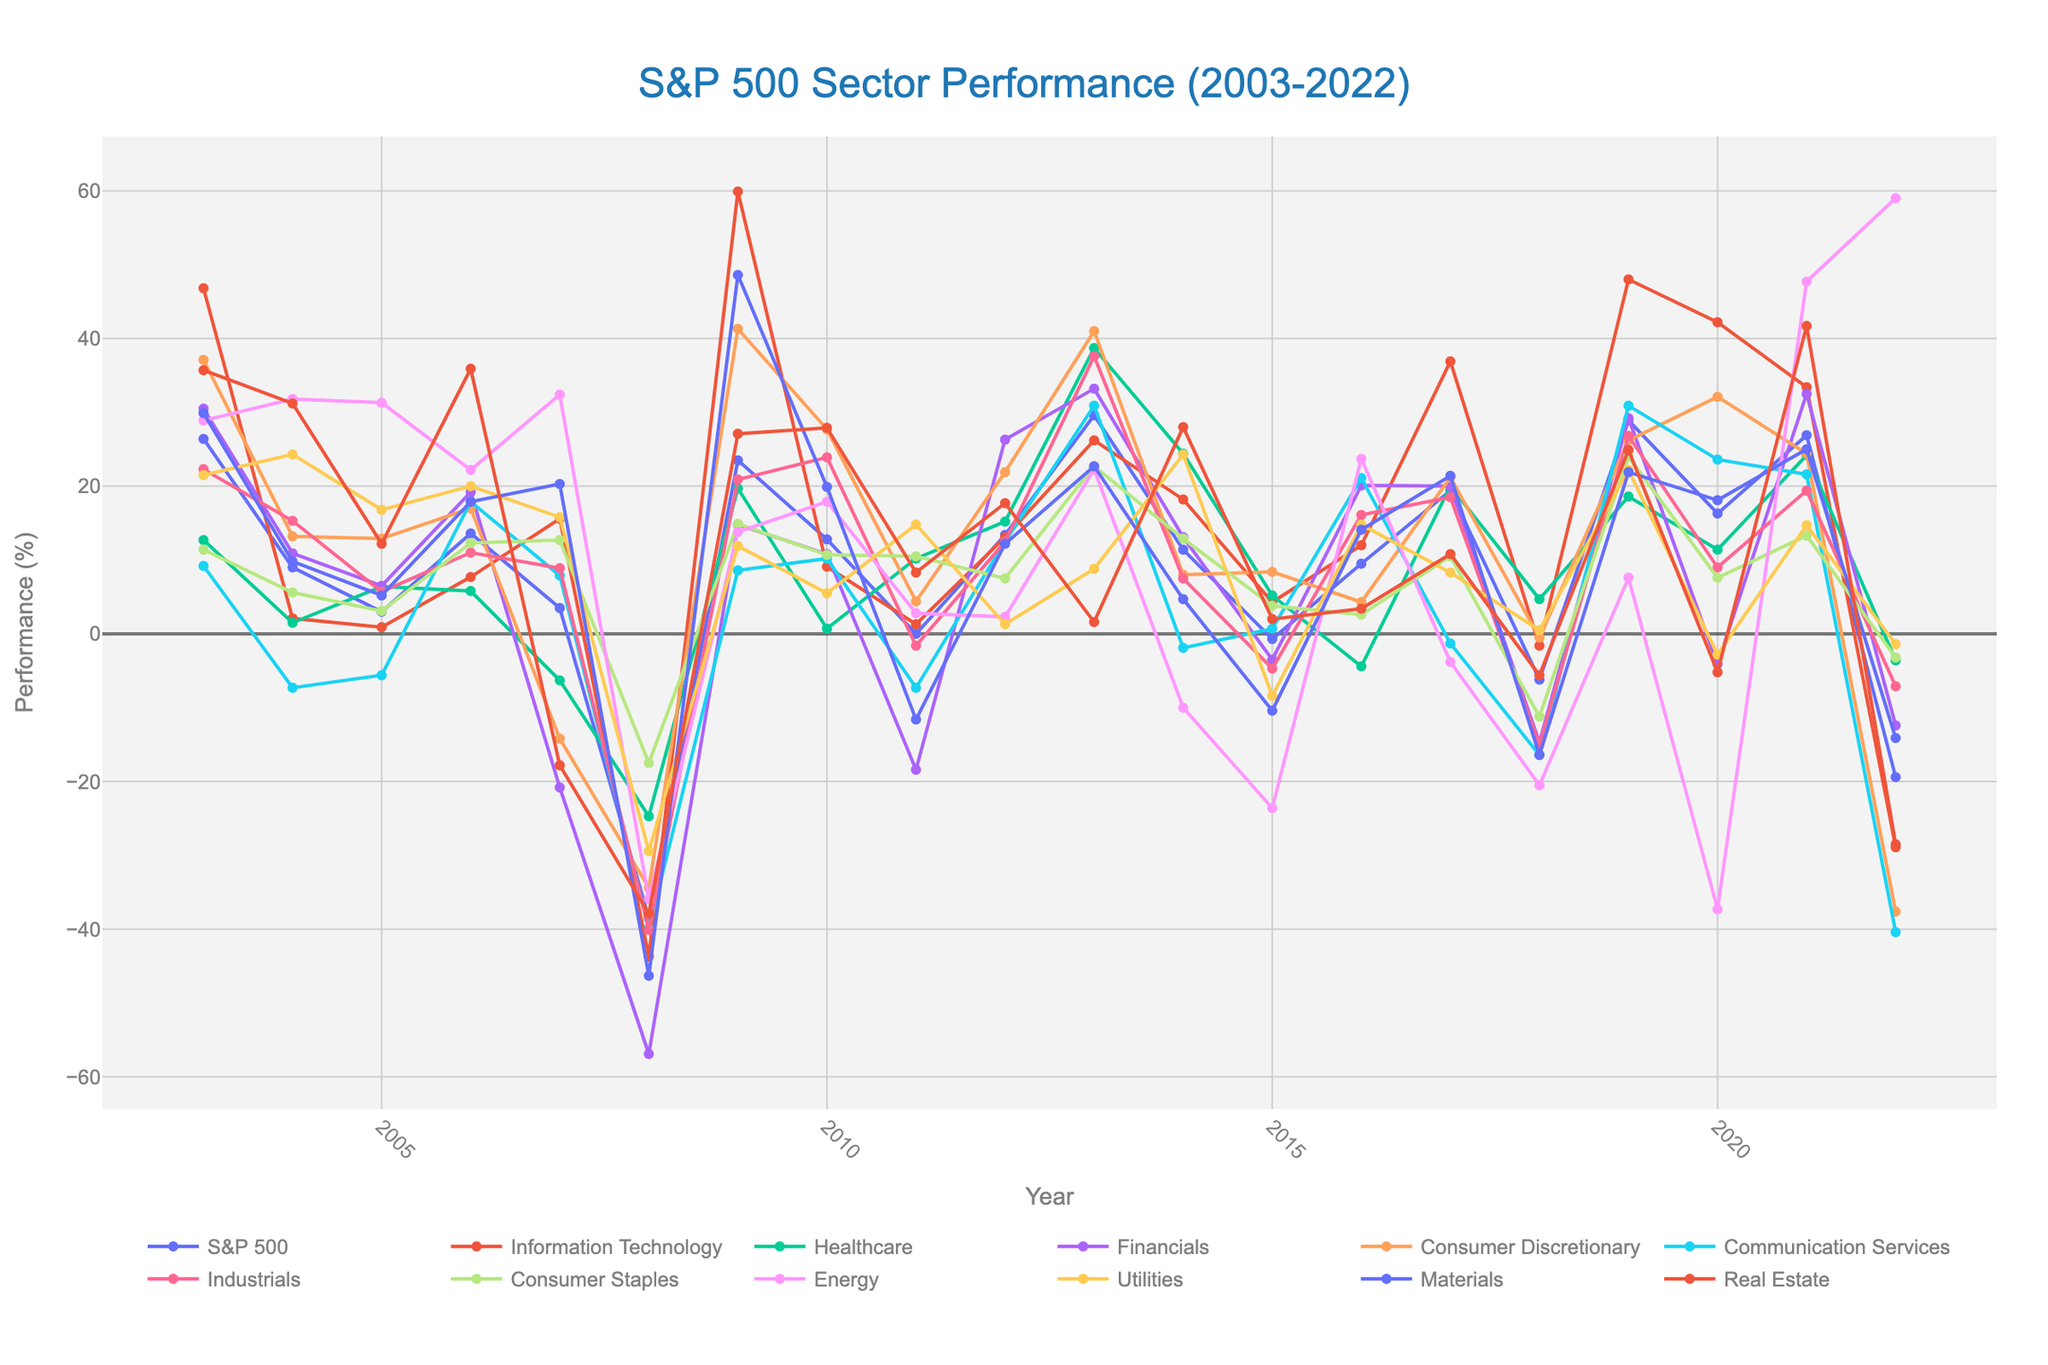What's the overall trend of the Information Technology sector from 2003 to 2022? Looking at the chart, the Information Technology sector shows a generally positive upward trend with significant peaks in 2009, 2013, 2019, 2020, and 2021, despite some downturns such as in 2008 and 2022.
Answer: Positive upward trend Which sector had the highest performance in 2008? Referring to the chart, all sectors experienced significant declines in 2008. However, Consumer Staples had the least negative performance, indicating it was the highest among poor performances.
Answer: Consumer Staples How did the Healthcare sector perform in 2011 compared to 2012? In the chart, the Healthcare sector had a performance of 10.2% in 2011 and improved to 15.2% in 2012. To compare: 15.2 - 10.2 = 5.0; hence, the Healthcare sector performed 5 percentage points better in 2012 than in 2011.
Answer: 5 percentage points better Which years show a negative performance for more than half of the sectors? Evaluating the chart, the years 2008, 2015, 2018, and 2022 display a negative performance for the majority of sectors. For instance, in 2008, almost every sector dropped, and similar trends can be observed in 2015, 2018, and 2022.
Answer: 2008, 2015, 2018, 2022 During which year did the Energy sector perform the worst, and what was its performance? According to the chart, the Energy sector experienced its worst performance in 2020 with a significant drop of -37.3%.
Answer: 2020, -37.3% How do the performances of the Consumer Discretionary and Financials sectors compare in 2007? From observing the chart, Consumer Discretionary had a performance of -14.2% while Financials had -20.8%. Consumer Discretionary performed better by 20.8 - 14.2 = 6.6 percentage points.
Answer: Consumer Discretionary performed 6.6 percentage points better What was the average performance across all sectors in 2017? Adding up the 11 sectors' performances in 2017 from the chart gives: 36.9 + 20.0 + 20.0 + 21.2 + (-1.3) + 18.5 + 10.5 + (-3.8) + 8.3 + 21.4 + 10.8 = 162.5. Dividing by 11 sectors, the average performance is 162.5 / 11 ≈ 14.8.
Answer: 14.8% Which sector shows the largest fluctuation in performance during the 20-year period? By analyzing the chart, Real Estate shows significant fluctuations, ranging from as high as 41.7% in 2021 to lows like -37.9% in 2008. Comparing these extremes indicates a fluctuation of 41.7 - (-37.9) = 79.6 percentage points.
Answer: Real Estate, 79.6 percentage points In which years did the Utilities sector show continuous growth for at least three consecutive years? From reviewing the chart, the Utilities sector showed continuous growth from 2003 to 2006 and from 2011 to 2014. Each of these periods shows at least three consecutive years of positive performance.
Answer: 2003-2006, 2011-2014 